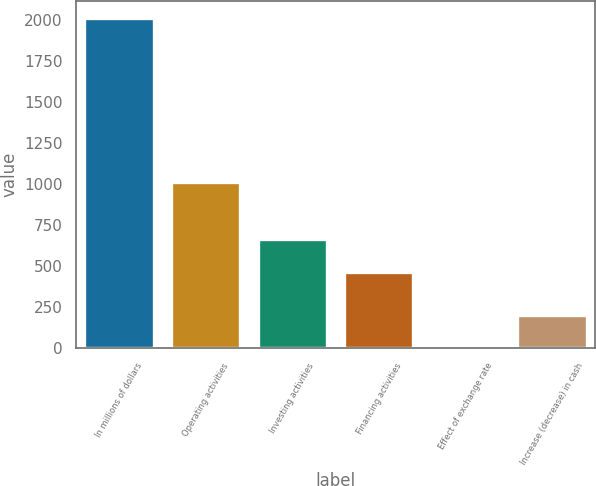<chart> <loc_0><loc_0><loc_500><loc_500><bar_chart><fcel>In millions of dollars<fcel>Operating activities<fcel>Investing activities<fcel>Financing activities<fcel>Effect of exchange rate<fcel>Increase (decrease) in cash<nl><fcel>2016<fcel>1013.4<fcel>665.69<fcel>464.4<fcel>3.1<fcel>204.39<nl></chart> 